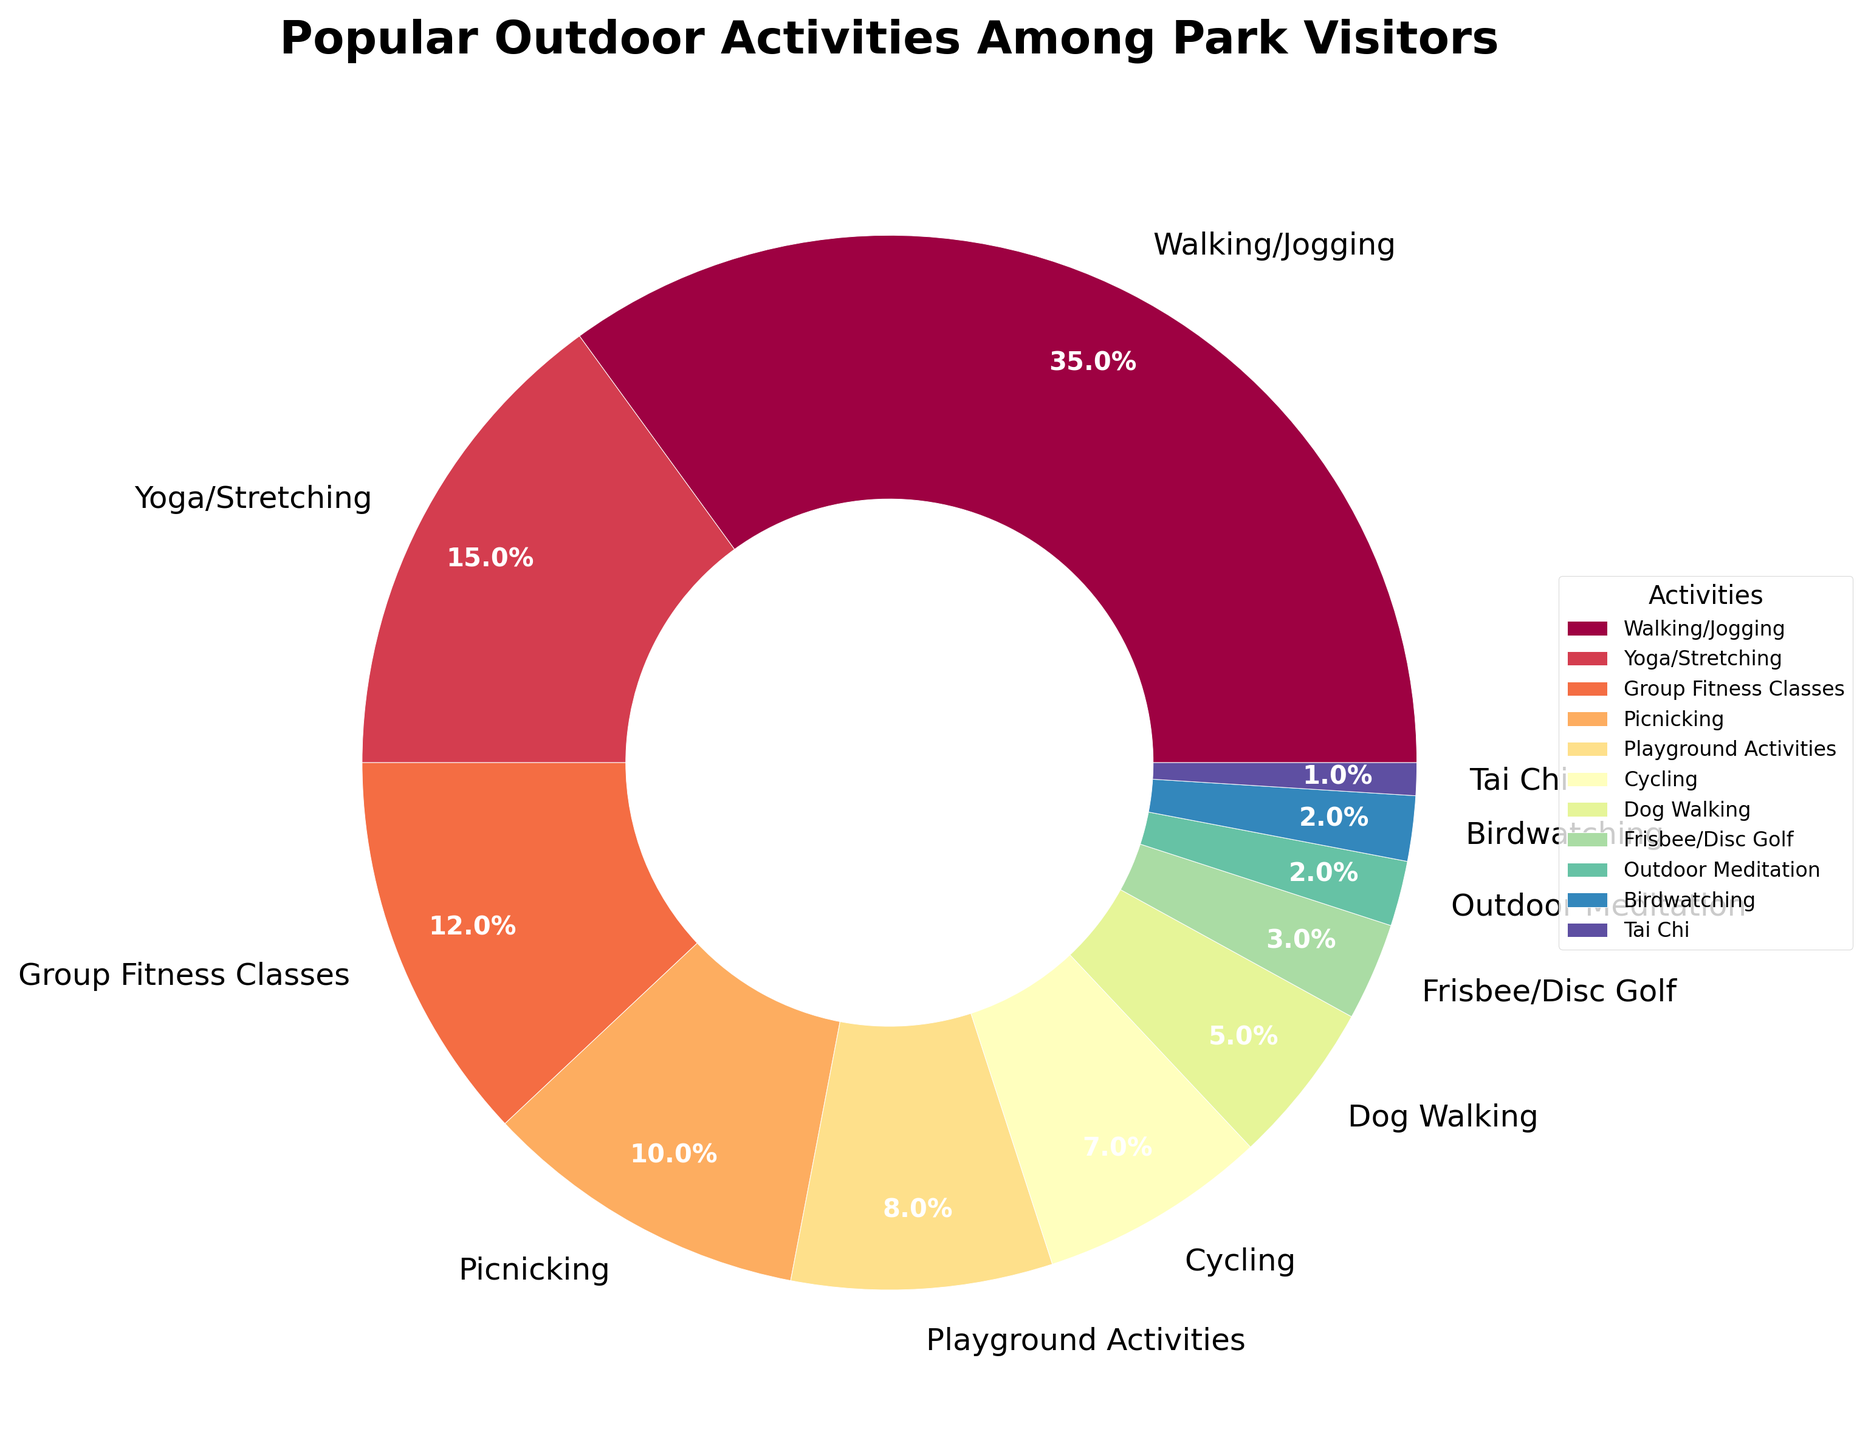Which activity has the highest percentage among park visitors? The pie chart shows that Walking/Jogging has the largest wedge, and the label indicates 35%.
Answer: Walking/Jogging How much more popular is Yoga/Stretching compared to Tai Chi? Yoga/Stretching is 15%, and Tai Chi is 1%. Subtracting the two gives 15% - 1% = 14%.
Answer: 14% What is the combined percentage of Playground Activities, Cycling, and Dog Walking? Playground Activities is 8%, Cycling is 7%, and Dog Walking is 5%. Adding them together gives 8% + 7% + 5% = 20%.
Answer: 20% Which activities have a smaller percentage than Picnicking? Picnicking is 10%. Activities with smaller percentages are Playground Activities (8%), Cycling (7%), Dog Walking (5%), Frisbee/Disc Golf (3%), Outdoor Meditation (2%), Birdwatching (2%), and Tai Chi (1%).
Answer: Playground Activities, Cycling, Dog Walking, Frisbee/Disc Golf, Outdoor Meditation, Birdwatching, Tai Chi What percentage of activities are Group Fitness Classes combined with Birdwatching? Group Fitness Classes is 12%, and Birdwatching is 2%. Adding them together gives 12% + 2% = 14%.
Answer: 14% Are there more visitors engaging in Frisbee/Disc Golf or Outdoor Meditation? Frisbee/Disc Golf is 3%, and Outdoor Meditation is 2%. Comparison shows that 3% > 2%.
Answer: Frisbee/Disc Golf What is the difference in percentage between Walking/Jogging and the least popular activity? Walking/Jogging is 35%, and the least popular, Tai Chi, is 1%. Subtracting them gives 35% - 1% = 34%.
Answer: 34% What are the top two most popular activities? The pie chart shows the two largest wedges: Walking/Jogging (35%) and Yoga/Stretching (15%).
Answer: Walking/Jogging, Yoga/Stretching How do the percentages for Dog Walking and Cycling compare? Dog Walking is 5%, and Cycling is 7%. Comparison shows that 7% > 5%.
Answer: Cycling What is the total percentage of all activities listed? Adding all percentages: 35% + 15% + 12% + 10% + 8% + 7% + 5% + 3% + 2% + 2% + 1% = 100%.
Answer: 100% 